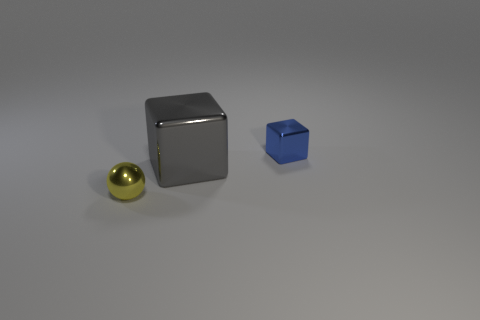Add 1 large green cubes. How many objects exist? 4 Subtract all cubes. How many objects are left? 1 Subtract 0 blue cylinders. How many objects are left? 3 Subtract all big shiny cubes. Subtract all gray cubes. How many objects are left? 1 Add 1 tiny blue blocks. How many tiny blue blocks are left? 2 Add 1 large gray cylinders. How many large gray cylinders exist? 1 